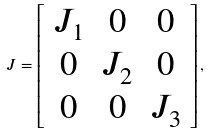<formula> <loc_0><loc_0><loc_500><loc_500>J = \left [ \begin{array} { c c c } J _ { 1 } & 0 & 0 \\ 0 & J _ { 2 } & 0 \\ 0 & 0 & J _ { 3 } \end{array} \right ] ,</formula> 